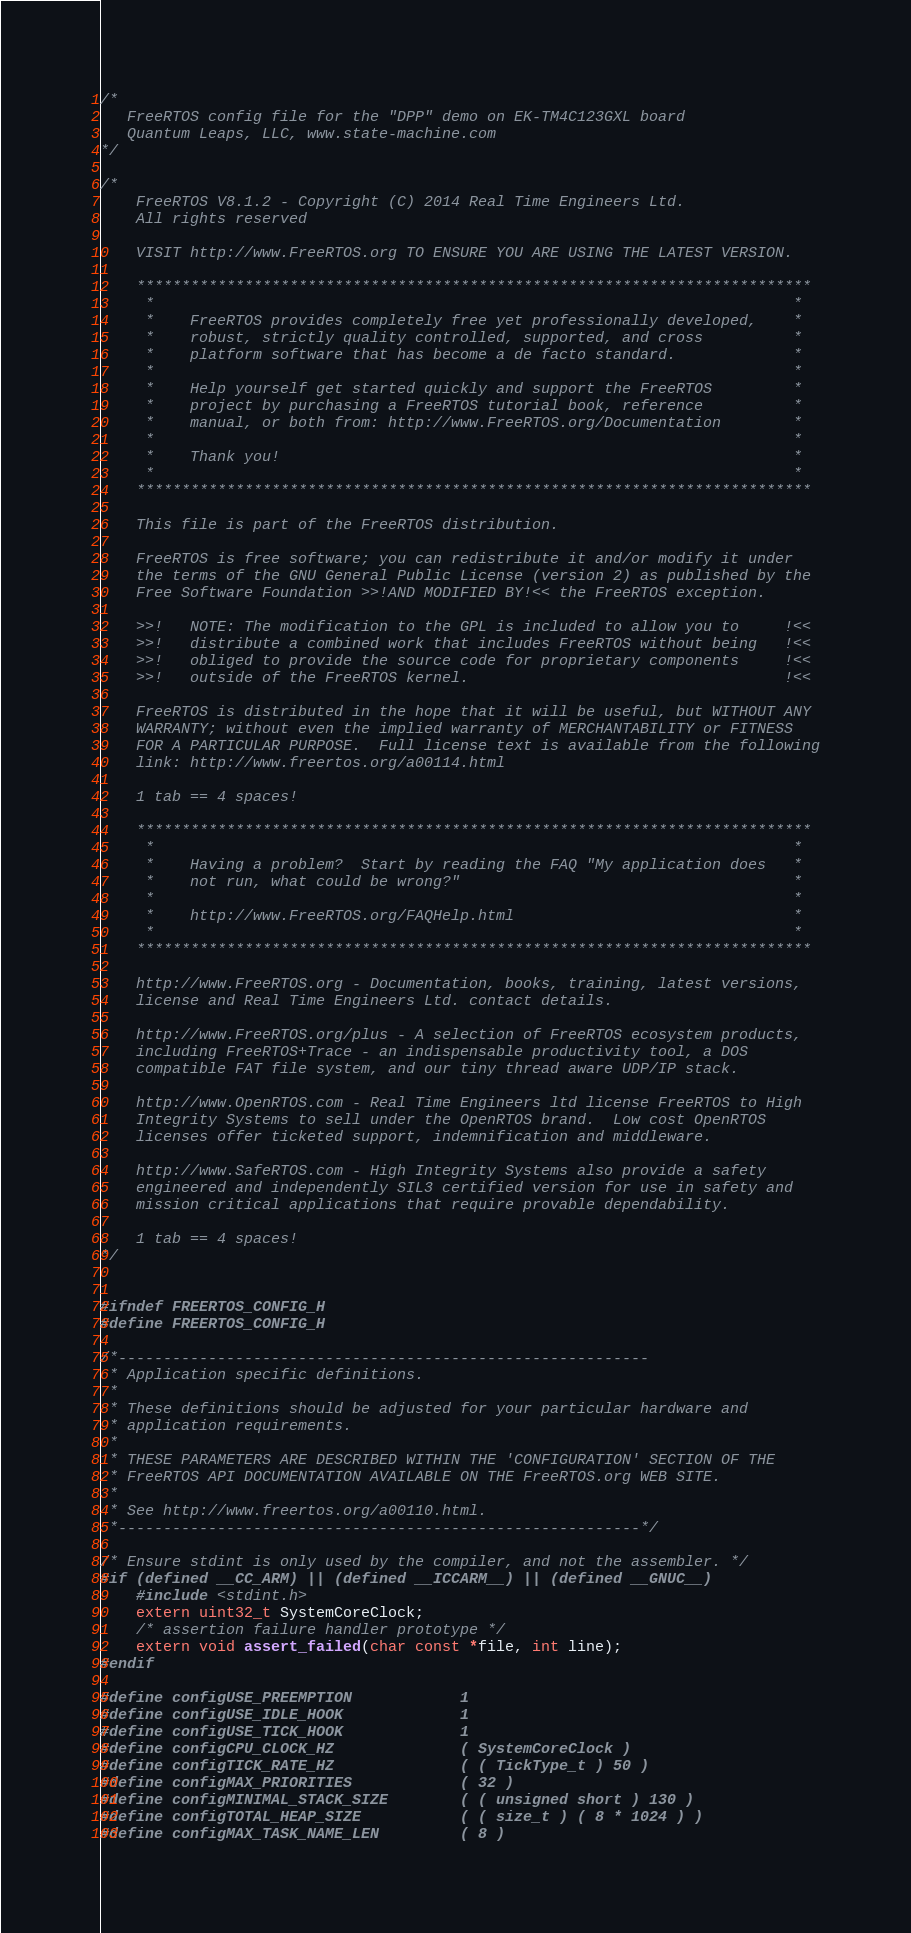Convert code to text. <code><loc_0><loc_0><loc_500><loc_500><_C_>/*
   FreeRTOS config file for the "DPP" demo on EK-TM4C123GXL board
   Quantum Leaps, LLC, www.state-machine.com
*/

/*
    FreeRTOS V8.1.2 - Copyright (C) 2014 Real Time Engineers Ltd.
    All rights reserved

    VISIT http://www.FreeRTOS.org TO ENSURE YOU ARE USING THE LATEST VERSION.

    ***************************************************************************
     *                                                                       *
     *    FreeRTOS provides completely free yet professionally developed,    *
     *    robust, strictly quality controlled, supported, and cross          *
     *    platform software that has become a de facto standard.             *
     *                                                                       *
     *    Help yourself get started quickly and support the FreeRTOS         *
     *    project by purchasing a FreeRTOS tutorial book, reference          *
     *    manual, or both from: http://www.FreeRTOS.org/Documentation        *
     *                                                                       *
     *    Thank you!                                                         *
     *                                                                       *
    ***************************************************************************

    This file is part of the FreeRTOS distribution.

    FreeRTOS is free software; you can redistribute it and/or modify it under
    the terms of the GNU General Public License (version 2) as published by the
    Free Software Foundation >>!AND MODIFIED BY!<< the FreeRTOS exception.

    >>!   NOTE: The modification to the GPL is included to allow you to     !<<
    >>!   distribute a combined work that includes FreeRTOS without being   !<<
    >>!   obliged to provide the source code for proprietary components     !<<
    >>!   outside of the FreeRTOS kernel.                                   !<<

    FreeRTOS is distributed in the hope that it will be useful, but WITHOUT ANY
    WARRANTY; without even the implied warranty of MERCHANTABILITY or FITNESS
    FOR A PARTICULAR PURPOSE.  Full license text is available from the following
    link: http://www.freertos.org/a00114.html

    1 tab == 4 spaces!

    ***************************************************************************
     *                                                                       *
     *    Having a problem?  Start by reading the FAQ "My application does   *
     *    not run, what could be wrong?"                                     *
     *                                                                       *
     *    http://www.FreeRTOS.org/FAQHelp.html                               *
     *                                                                       *
    ***************************************************************************

    http://www.FreeRTOS.org - Documentation, books, training, latest versions,
    license and Real Time Engineers Ltd. contact details.

    http://www.FreeRTOS.org/plus - A selection of FreeRTOS ecosystem products,
    including FreeRTOS+Trace - an indispensable productivity tool, a DOS
    compatible FAT file system, and our tiny thread aware UDP/IP stack.

    http://www.OpenRTOS.com - Real Time Engineers ltd license FreeRTOS to High
    Integrity Systems to sell under the OpenRTOS brand.  Low cost OpenRTOS
    licenses offer ticketed support, indemnification and middleware.

    http://www.SafeRTOS.com - High Integrity Systems also provide a safety
    engineered and independently SIL3 certified version for use in safety and
    mission critical applications that require provable dependability.

    1 tab == 4 spaces!
*/


#ifndef FREERTOS_CONFIG_H
#define FREERTOS_CONFIG_H

/*-----------------------------------------------------------
 * Application specific definitions.
 *
 * These definitions should be adjusted for your particular hardware and
 * application requirements.
 *
 * THESE PARAMETERS ARE DESCRIBED WITHIN THE 'CONFIGURATION' SECTION OF THE
 * FreeRTOS API DOCUMENTATION AVAILABLE ON THE FreeRTOS.org WEB SITE.
 *
 * See http://www.freertos.org/a00110.html.
 *----------------------------------------------------------*/

/* Ensure stdint is only used by the compiler, and not the assembler. */
#if (defined __CC_ARM) || (defined __ICCARM__) || (defined __GNUC__)
    #include <stdint.h>
    extern uint32_t SystemCoreClock;
    /* assertion failure handler prototype */
    extern void assert_failed(char const *file, int line);
#endif

#define configUSE_PREEMPTION            1
#define configUSE_IDLE_HOOK             1
#define configUSE_TICK_HOOK             1
#define configCPU_CLOCK_HZ              ( SystemCoreClock )
#define configTICK_RATE_HZ              ( ( TickType_t ) 50 )
#define configMAX_PRIORITIES            ( 32 )
#define configMINIMAL_STACK_SIZE        ( ( unsigned short ) 130 )
#define configTOTAL_HEAP_SIZE           ( ( size_t ) ( 8 * 1024 ) )
#define configMAX_TASK_NAME_LEN         ( 8 )</code> 